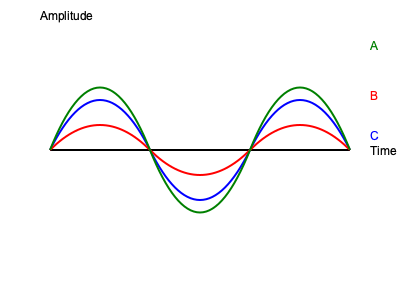As a music teacher who appreciates the fusion of visual and auditory artistry, analyze the waveforms A, B, and C shown in the graph. Which waveform corresponds to the highest pitch musical note? To determine which waveform corresponds to the highest pitch musical note, we need to follow these steps:

1. Understand the relationship between frequency and pitch:
   - Higher frequency corresponds to higher pitch
   - Lower frequency corresponds to lower pitch

2. Analyze the waveforms:
   - Waveform A (green) has the highest peak and the shortest wavelength
   - Waveform B (red) has a medium peak and medium wavelength
   - Waveform C (blue) has the lowest peak and the longest wavelength

3. Compare frequencies:
   - Frequency is inversely proportional to wavelength
   - Shorter wavelength means higher frequency
   - Longer wavelength means lower frequency

4. Rank the waveforms by frequency (highest to lowest):
   A > B > C

5. Relate frequency to pitch:
   - Since higher frequency corresponds to higher pitch, the waveform with the highest frequency will represent the highest pitch musical note

Therefore, waveform A, with the shortest wavelength and highest frequency, corresponds to the highest pitch musical note.
Answer: Waveform A 